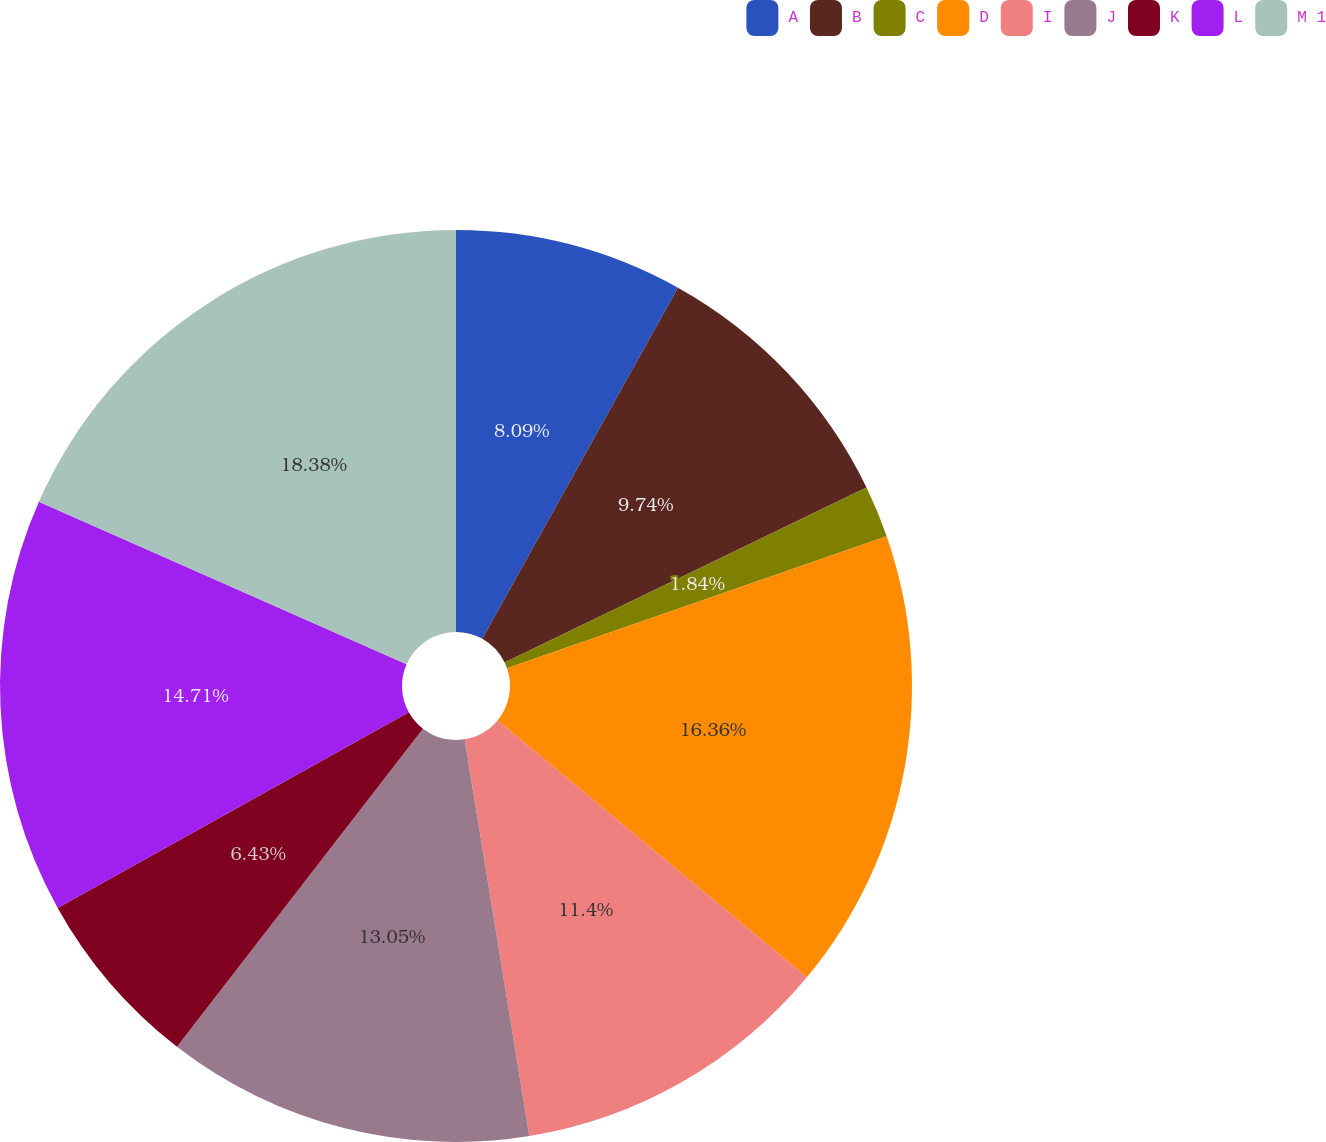<chart> <loc_0><loc_0><loc_500><loc_500><pie_chart><fcel>A<fcel>B<fcel>C<fcel>D<fcel>I<fcel>J<fcel>K<fcel>L<fcel>M 1<nl><fcel>8.09%<fcel>9.74%<fcel>1.84%<fcel>16.36%<fcel>11.4%<fcel>13.05%<fcel>6.43%<fcel>14.71%<fcel>18.38%<nl></chart> 